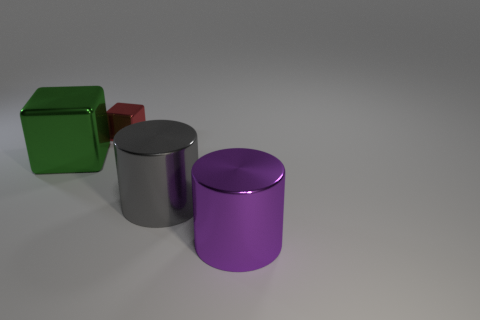Add 4 small metallic objects. How many objects exist? 8 Subtract 0 purple blocks. How many objects are left? 4 Subtract all small red objects. Subtract all purple things. How many objects are left? 2 Add 4 big purple metal things. How many big purple metal things are left? 5 Add 2 gray cylinders. How many gray cylinders exist? 3 